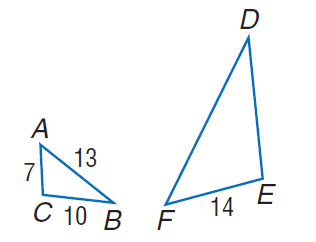Answer the mathemtical geometry problem and directly provide the correct option letter.
Question: Find the perimeter of \triangle D E F, if \triangle D E F \sim \triangle A C B.
Choices: A: 28 B: 30 C: 42 D: 49 C 